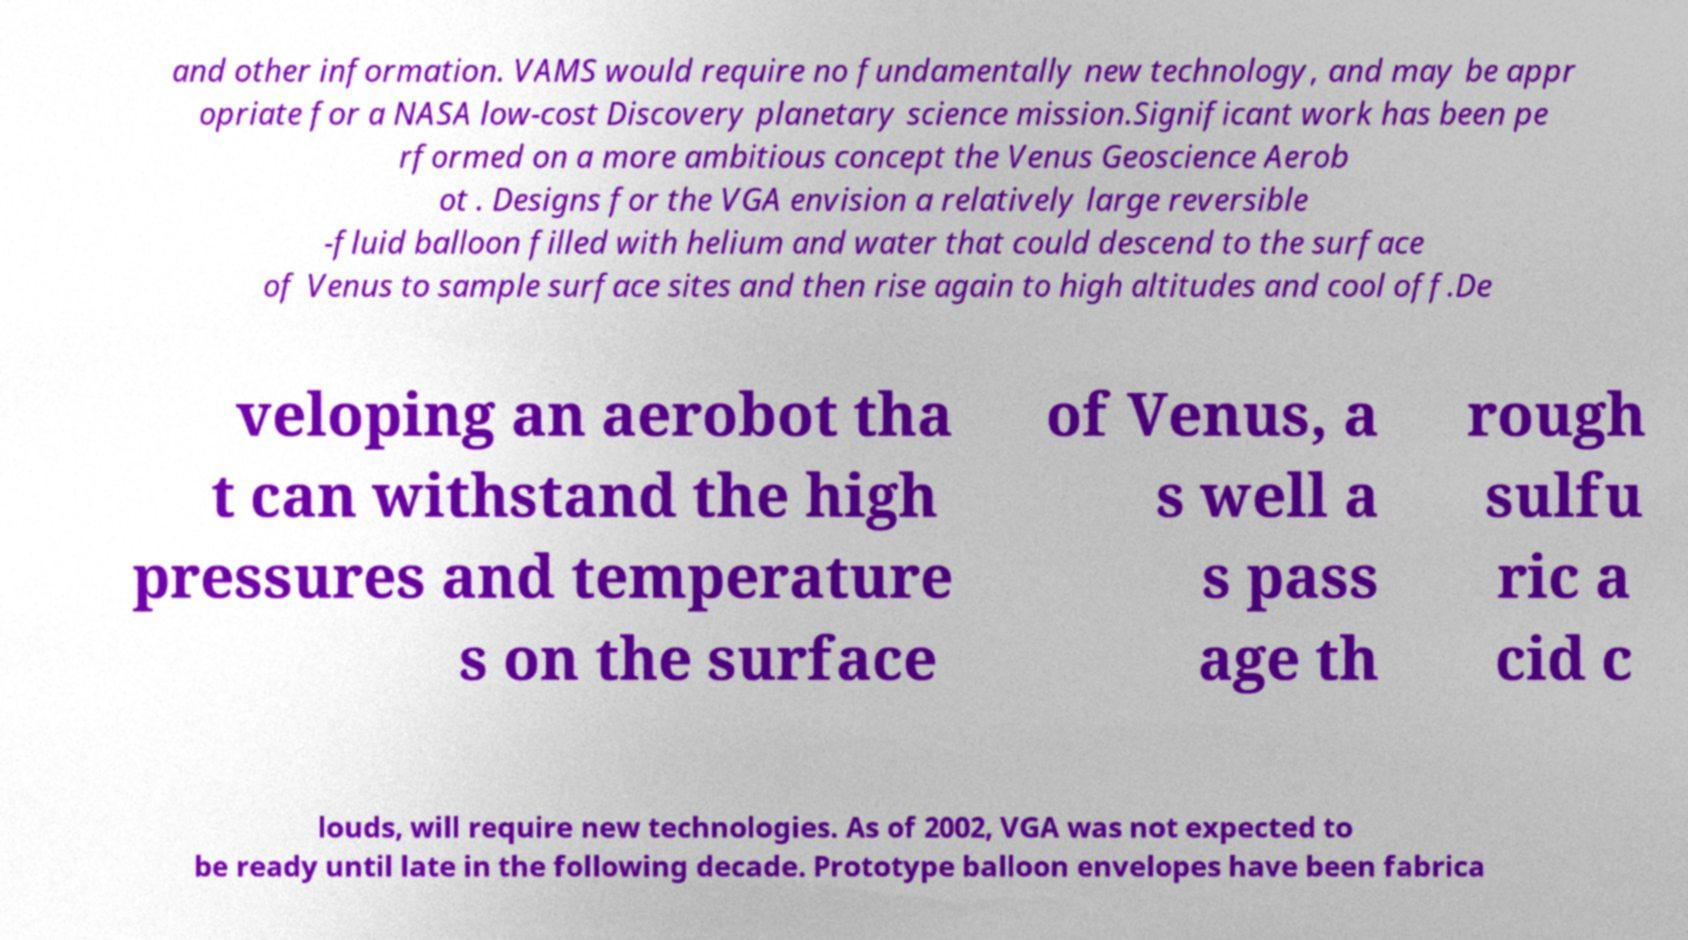Please identify and transcribe the text found in this image. and other information. VAMS would require no fundamentally new technology, and may be appr opriate for a NASA low-cost Discovery planetary science mission.Significant work has been pe rformed on a more ambitious concept the Venus Geoscience Aerob ot . Designs for the VGA envision a relatively large reversible -fluid balloon filled with helium and water that could descend to the surface of Venus to sample surface sites and then rise again to high altitudes and cool off.De veloping an aerobot tha t can withstand the high pressures and temperature s on the surface of Venus, a s well a s pass age th rough sulfu ric a cid c louds, will require new technologies. As of 2002, VGA was not expected to be ready until late in the following decade. Prototype balloon envelopes have been fabrica 